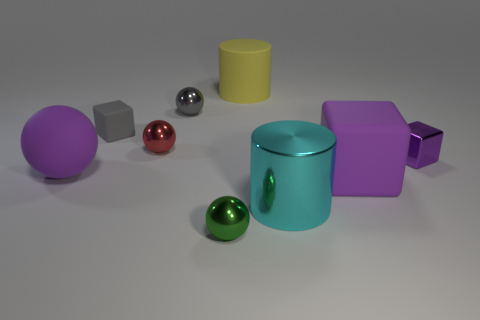What shape is the large object behind the rubber cube left of the small green metal thing?
Provide a short and direct response. Cylinder. There is a rubber thing that is in front of the large yellow rubber cylinder and behind the purple sphere; what is its size?
Make the answer very short. Small. Is there a large blue thing of the same shape as the small green metal object?
Your answer should be compact. No. Is there any other thing that has the same shape as the yellow object?
Make the answer very short. Yes. What is the material of the sphere that is in front of the rubber object that is left of the small cube that is behind the purple metal block?
Your answer should be compact. Metal. Is there a gray rubber thing that has the same size as the purple rubber ball?
Your answer should be compact. No. What is the color of the cube that is on the right side of the cube that is in front of the small purple metallic cube?
Give a very brief answer. Purple. What number of small purple blocks are there?
Give a very brief answer. 1. Is the color of the small shiny cube the same as the metallic cylinder?
Your response must be concise. No. Are there fewer cylinders that are behind the big cyan metal thing than tiny red metallic spheres that are to the right of the large matte block?
Your answer should be very brief. No. 